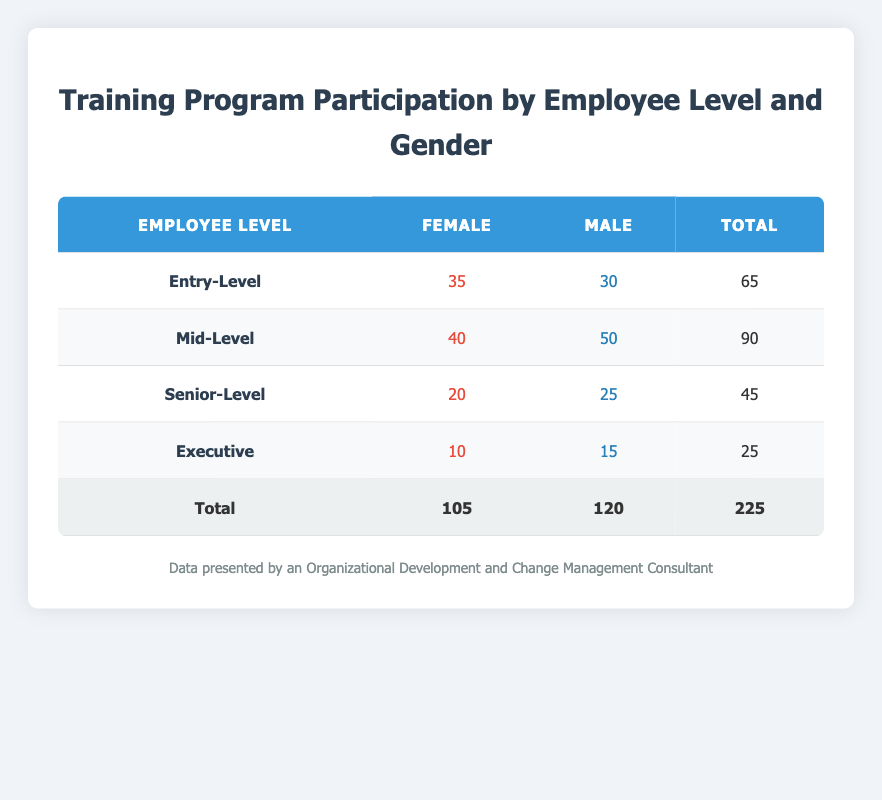What is the total participation count for Senior-Level employees? Looking at the "Senior-Level" row in the table, the participation count is provided for both genders, which are 20 for females and 25 for males. Adding those together gives us 20 + 25 = 45.
Answer: 45 What gender had higher participation in Mid-Level positions? The table shows 40 females and 50 males in the Mid-Level category. Since 50 is greater than 40, males had higher participation.
Answer: Male What is the total number of participants across all Employee Levels? The total counts for each employee level are provided: Entry-Level (65), Mid-Level (90), Senior-Level (45), and Executive (25). Adding these totals gives 65 + 90 + 45 + 25 = 225.
Answer: 225 Is there a higher participation of females or males at the Entry-Level? The table shows that females had 35 participants while males had 30 at Entry-Level. Since 35 is greater than 30, females had higher participation.
Answer: Female What is the average participation count for female employees across all levels? The participation counts are: 35 for Entry-Level, 40 for Mid-Level, 20 for Senior-Level, and 10 for Executive, totaling to 35 + 40 + 20 + 10 = 105. There are 4 levels, so the average is 105 / 4 = 26.25.
Answer: 26.25 What is the difference in participation count between male and female employees at the Executive level? The table shows 10 females and 15 males in the Executive level. The difference can be calculated by subtracting the female count from the male count: 15 - 10 = 5.
Answer: 5 Which Employee Level has the least participation overall? Summing the total participation counts for each level: Entry-Level (65), Mid-Level (90), Senior-Level (45), Executive (25) shows Executive has the least with 25 total participants.
Answer: Executive If we combine the participation counts for all levels of female employees, what is that total? The female participation counts are 35 for Entry-Level, 40 for Mid-Level, 20 for Senior-Level, and 10 for Executive. Adding these gives 35 + 40 + 20 + 10 = 105.
Answer: 105 Which gender has the highest total participation across all Employee Levels? Summing the totals for males gives 30 + 50 + 25 + 15 = 120, while for females it is 35 + 40 + 20 + 10 = 105. Since 120 is greater than 105, males have the highest total participation.
Answer: Male 